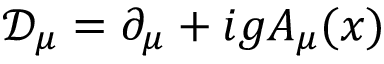<formula> <loc_0><loc_0><loc_500><loc_500>{ \mathcal { D } } _ { \mu } = \partial _ { \mu } + i g A _ { \mu } ( x )</formula> 